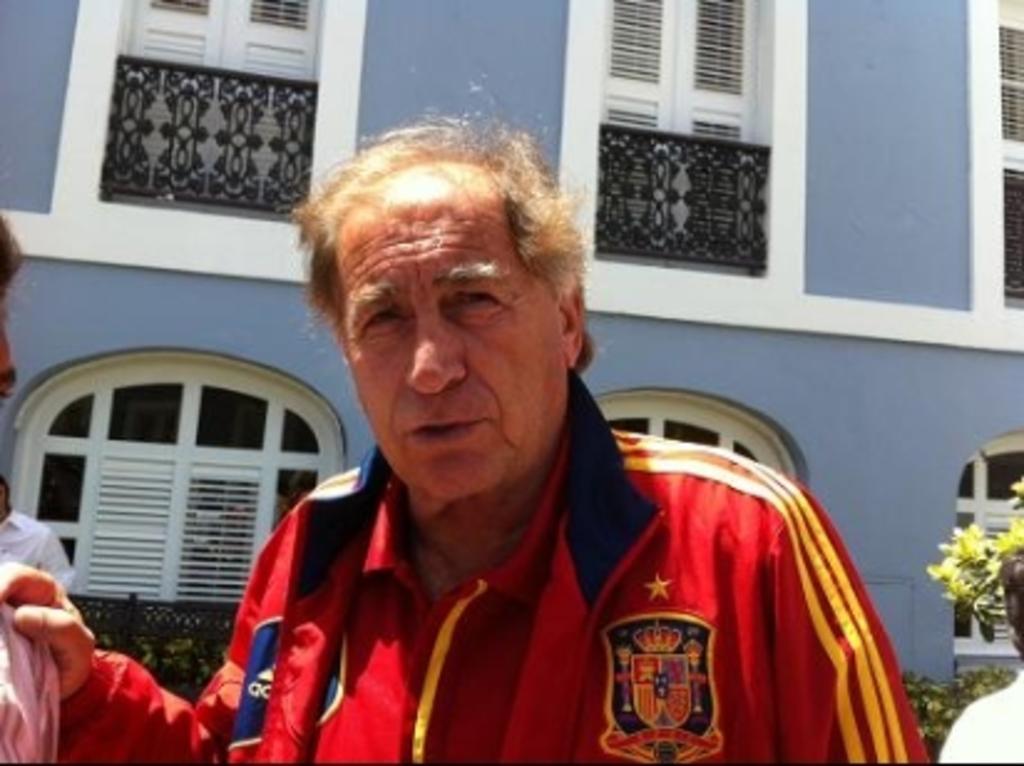How would you summarize this image in a sentence or two? As we can see in the image there are few people standing in the front. There is a fence, plants, tree, building and windows. 